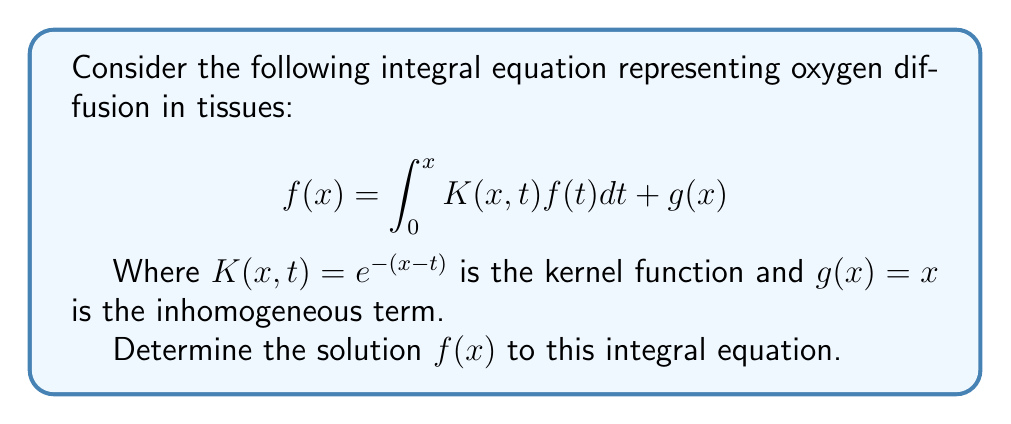Can you solve this math problem? To solve this integral equation, we'll use the method of successive approximations:

1) Start with an initial guess $f_0(x) = g(x) = x$

2) Iterate using the formula:
   $$f_{n+1}(x) = \int_0^x K(x,t)f_n(t)dt + g(x)$$

3) First iteration:
   $$\begin{align*}
   f_1(x) &= \int_0^x e^{-(x-t)}t dt + x \\
   &= e^{-x}\int_0^x e^t t dt + x \\
   &= e^{-x}(xe^x - e^x + 1) + x \\
   &= x - 1 + e^{-x}
   \end{align*}$$

4) Second iteration:
   $$\begin{align*}
   f_2(x) &= \int_0^x e^{-(x-t)}(t - 1 + e^{-t}) dt + x \\
   &= e^{-x}\int_0^x e^t(t - 1 + e^{-t}) dt + x \\
   &= e^{-x}[(xe^x - e^x + 1) - (e^x - 1) + (1 - e^{-x})] + x \\
   &= x - 2 + 2e^{-x}
   \end{align*}$$

5) Third iteration:
   $$\begin{align*}
   f_3(x) &= \int_0^x e^{-(x-t)}(t - 2 + 2e^{-t}) dt + x \\
   &= e^{-x}\int_0^x e^t(t - 2 + 2e^{-t}) dt + x \\
   &= e^{-x}[(xe^x - e^x + 1) - 2(e^x - 1) + 2(1 - e^{-x})] + x \\
   &= x - 3 + 3e^{-x}
   \end{align*}$$

6) We can see a pattern forming. The general term appears to be:
   $$f_n(x) = x - n + ne^{-x}$$

7) As $n$ approaches infinity, this converges to:
   $$f(x) = \lim_{n\to\infty} (x - n + ne^{-x}) = x - \frac{1}{1-e^{-x}}$$

8) We can verify this solution by substituting it back into the original equation:
   $$\begin{align*}
   \int_0^x K(x,t)f(t)dt + g(x) &= \int_0^x e^{-(x-t)}(t - \frac{1}{1-e^{-t}})dt + x \\
   &= e^{-x}\int_0^x e^t(t - \frac{1}{1-e^{-t}})dt + x \\
   &= e^{-x}[(xe^x - e^x + 1) - (\ln(1-e^{-x}) + x)] + x \\
   &= x - 1 + e^{-x} - \ln(1-e^{-x}) - xe^{-x} + x \\
   &= x - \frac{1}{1-e^{-x}} \\
   &= f(x)
   \end{align*}$$

Thus, we have confirmed that our solution satisfies the original integral equation.
Answer: $f(x) = x - \frac{1}{1-e^{-x}}$ 